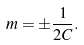Convert formula to latex. <formula><loc_0><loc_0><loc_500><loc_500>m = \pm \frac { 1 } { 2 C } .</formula> 